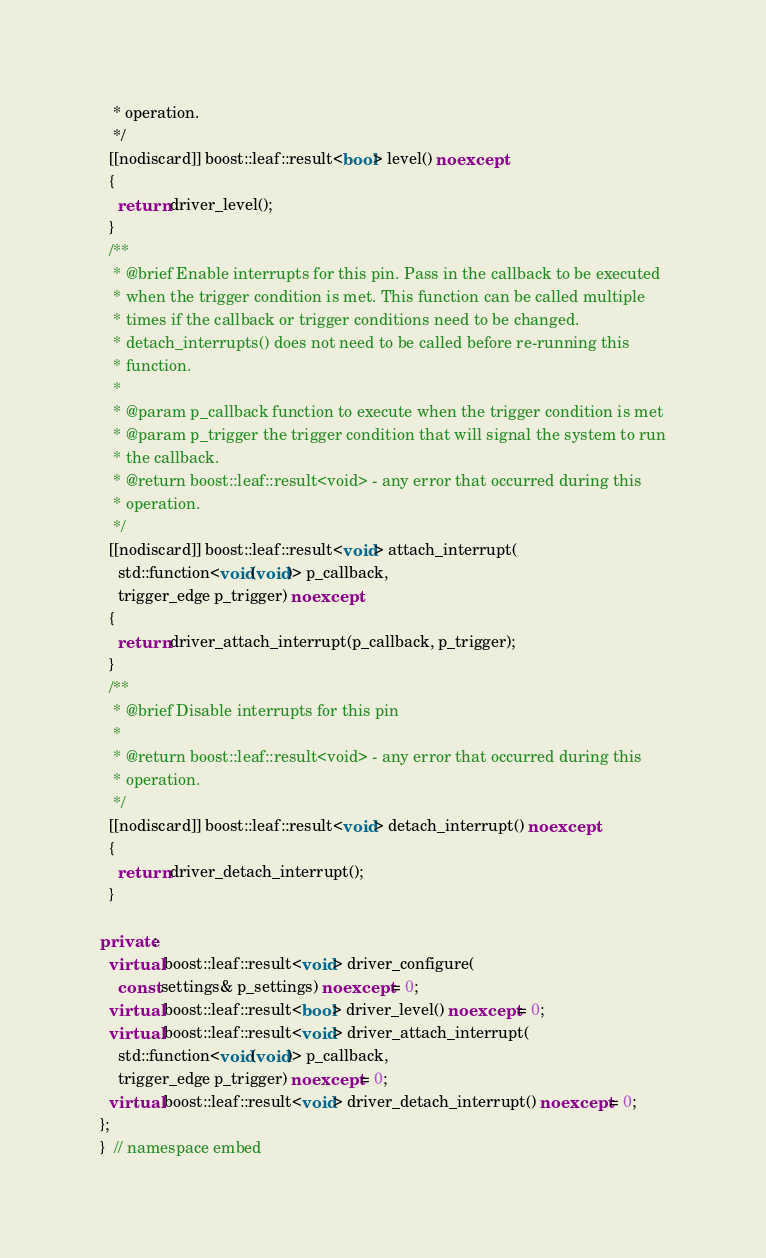<code> <loc_0><loc_0><loc_500><loc_500><_C++_>   * operation.
   */
  [[nodiscard]] boost::leaf::result<bool> level() noexcept
  {
    return driver_level();
  }
  /**
   * @brief Enable interrupts for this pin. Pass in the callback to be executed
   * when the trigger condition is met. This function can be called multiple
   * times if the callback or trigger conditions need to be changed.
   * detach_interrupts() does not need to be called before re-running this
   * function.
   *
   * @param p_callback function to execute when the trigger condition is met
   * @param p_trigger the trigger condition that will signal the system to run
   * the callback.
   * @return boost::leaf::result<void> - any error that occurred during this
   * operation.
   */
  [[nodiscard]] boost::leaf::result<void> attach_interrupt(
    std::function<void(void)> p_callback,
    trigger_edge p_trigger) noexcept
  {
    return driver_attach_interrupt(p_callback, p_trigger);
  }
  /**
   * @brief Disable interrupts for this pin
   *
   * @return boost::leaf::result<void> - any error that occurred during this
   * operation.
   */
  [[nodiscard]] boost::leaf::result<void> detach_interrupt() noexcept
  {
    return driver_detach_interrupt();
  }

private:
  virtual boost::leaf::result<void> driver_configure(
    const settings& p_settings) noexcept = 0;
  virtual boost::leaf::result<bool> driver_level() noexcept = 0;
  virtual boost::leaf::result<void> driver_attach_interrupt(
    std::function<void(void)> p_callback,
    trigger_edge p_trigger) noexcept = 0;
  virtual boost::leaf::result<void> driver_detach_interrupt() noexcept = 0;
};
}  // namespace embed
</code> 